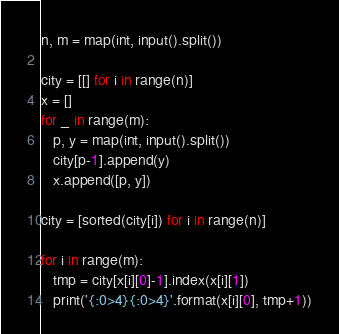<code> <loc_0><loc_0><loc_500><loc_500><_Python_>n, m = map(int, input().split())

city = [[] for i in range(n)]
x = []
for _ in range(m):
   p, y = map(int, input().split())
   city[p-1].append(y)
   x.append([p, y])

city = [sorted(city[i]) for i in range(n)]

for i in range(m):
   tmp = city[x[i][0]-1].index(x[i][1])
   print('{:0>4}{:0>4}'.format(x[i][0], tmp+1))
</code> 